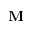Convert formula to latex. <formula><loc_0><loc_0><loc_500><loc_500>M</formula> 